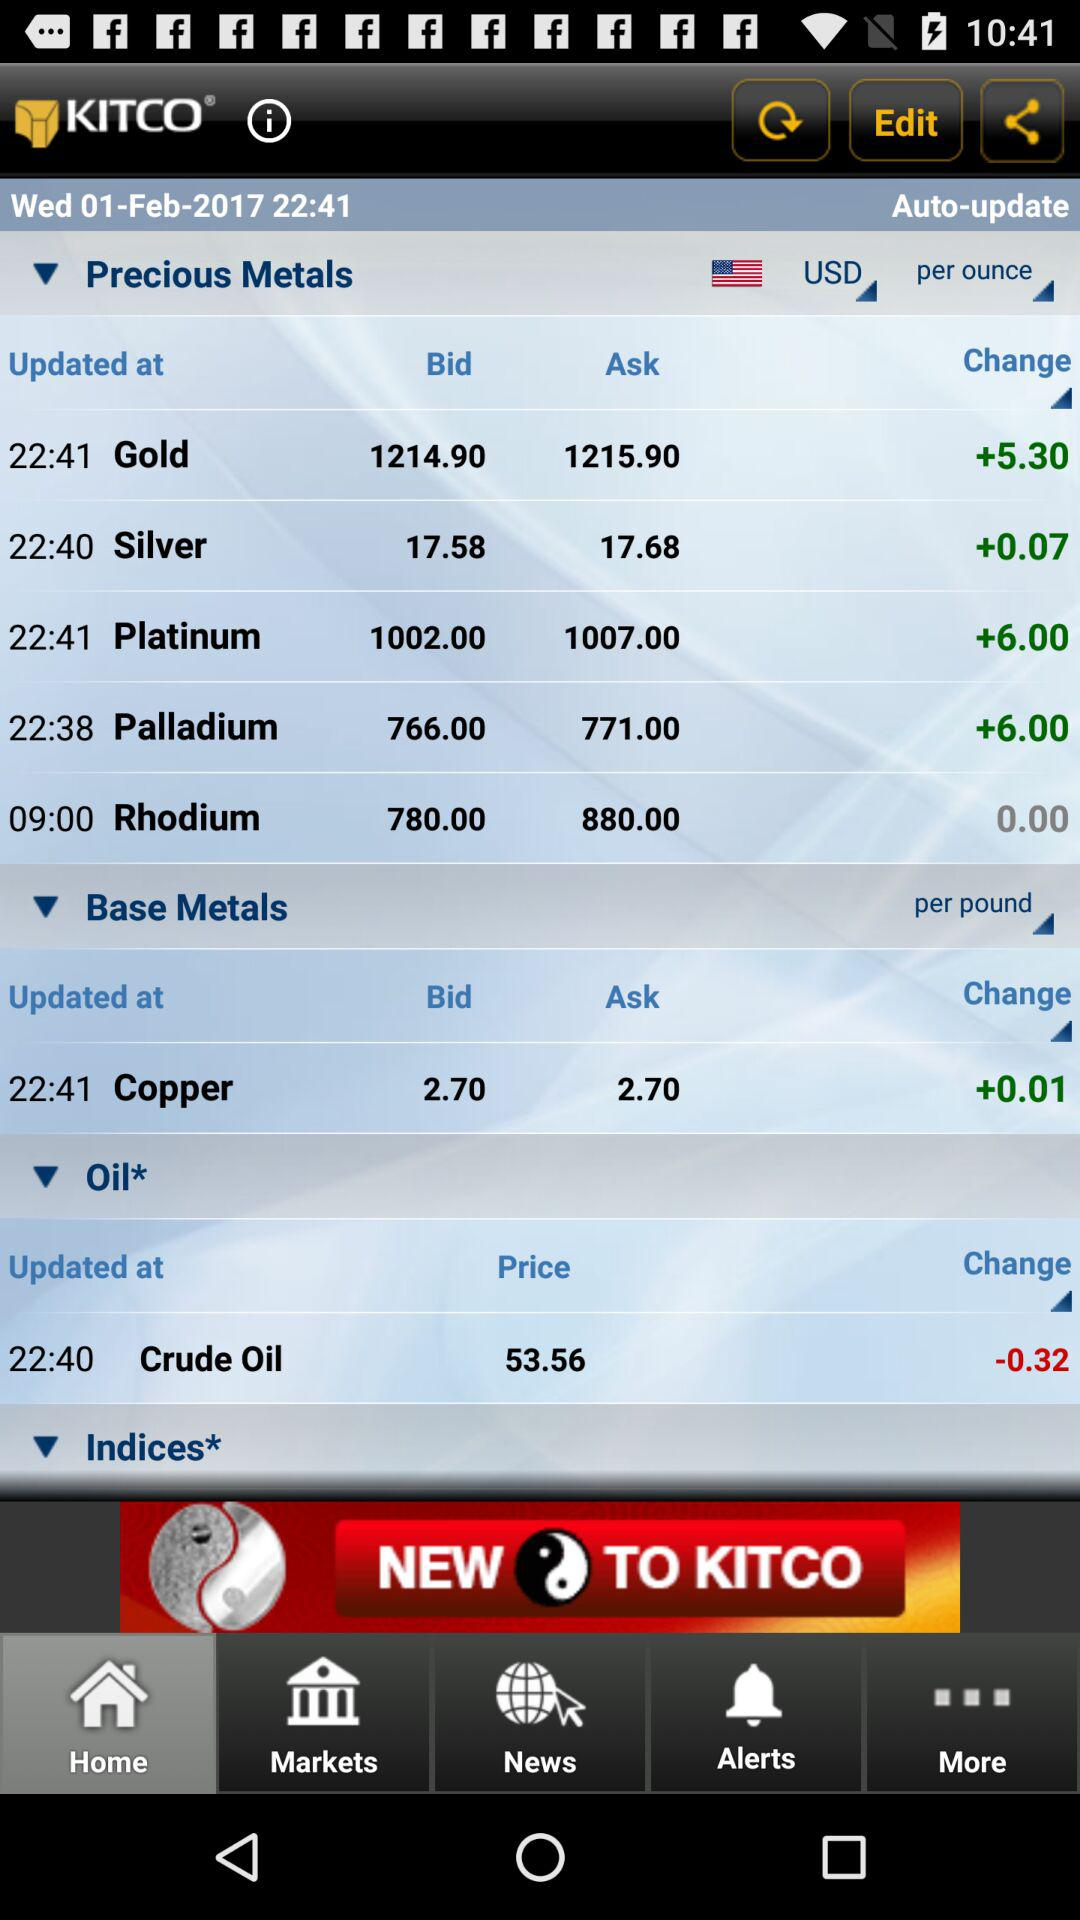At what time was "Copper" updated? The "Copper" was updated at 22:41. 